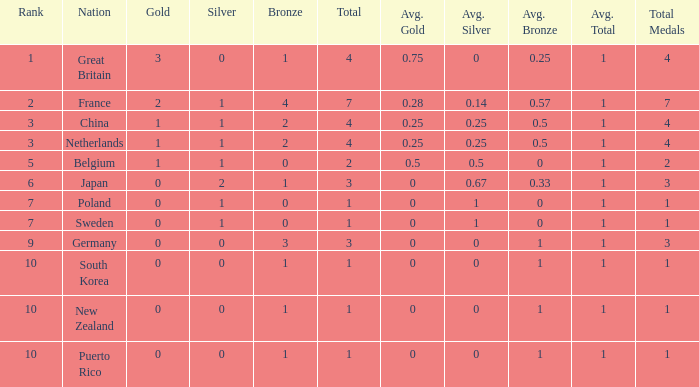What is the smallest number of gold where the total is less than 3 and the silver count is 2? None. 